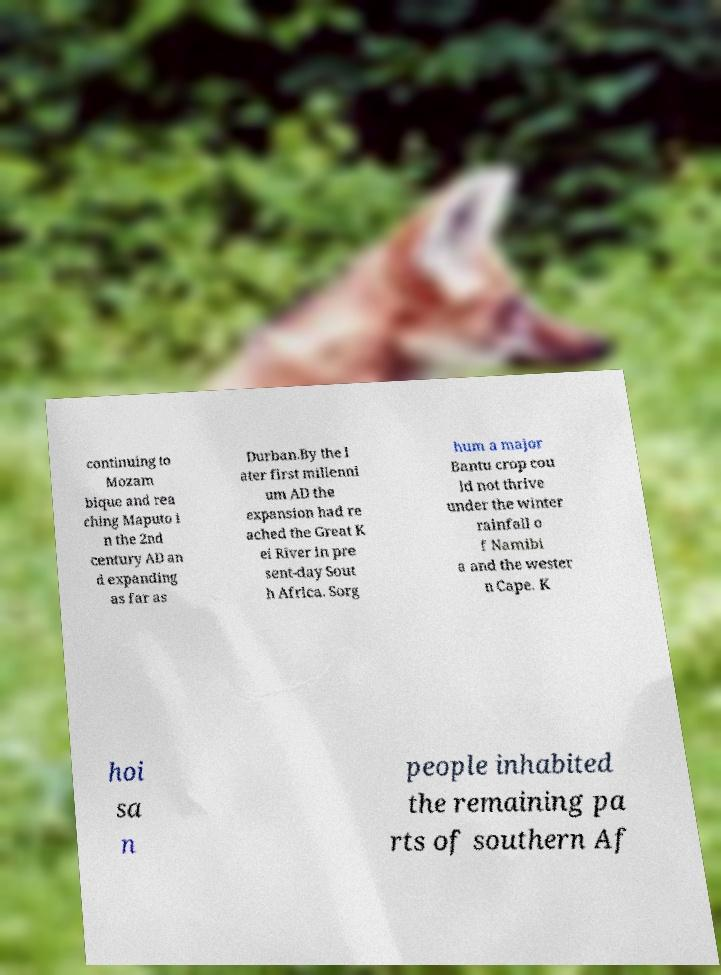There's text embedded in this image that I need extracted. Can you transcribe it verbatim? continuing to Mozam bique and rea ching Maputo i n the 2nd century AD an d expanding as far as Durban.By the l ater first millenni um AD the expansion had re ached the Great K ei River in pre sent-day Sout h Africa. Sorg hum a major Bantu crop cou ld not thrive under the winter rainfall o f Namibi a and the wester n Cape. K hoi sa n people inhabited the remaining pa rts of southern Af 